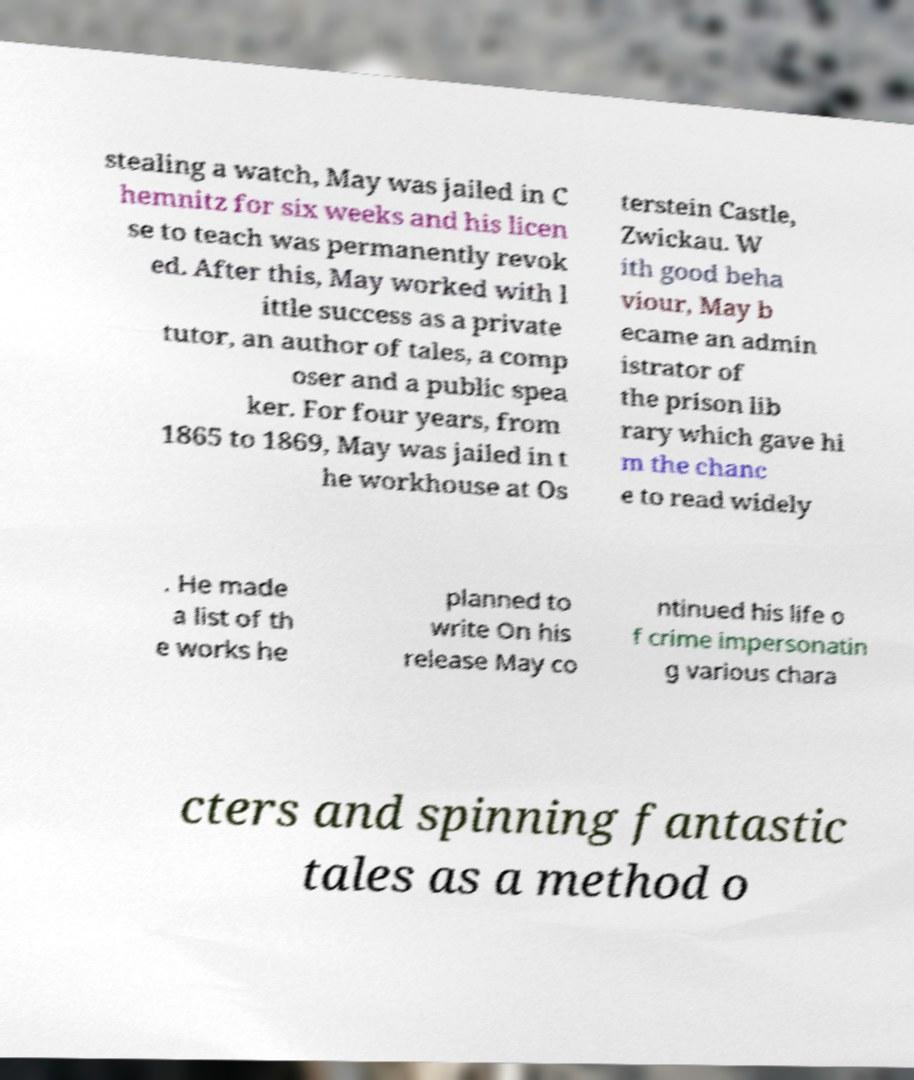Can you accurately transcribe the text from the provided image for me? stealing a watch, May was jailed in C hemnitz for six weeks and his licen se to teach was permanently revok ed. After this, May worked with l ittle success as a private tutor, an author of tales, a comp oser and a public spea ker. For four years, from 1865 to 1869, May was jailed in t he workhouse at Os terstein Castle, Zwickau. W ith good beha viour, May b ecame an admin istrator of the prison lib rary which gave hi m the chanc e to read widely . He made a list of th e works he planned to write On his release May co ntinued his life o f crime impersonatin g various chara cters and spinning fantastic tales as a method o 